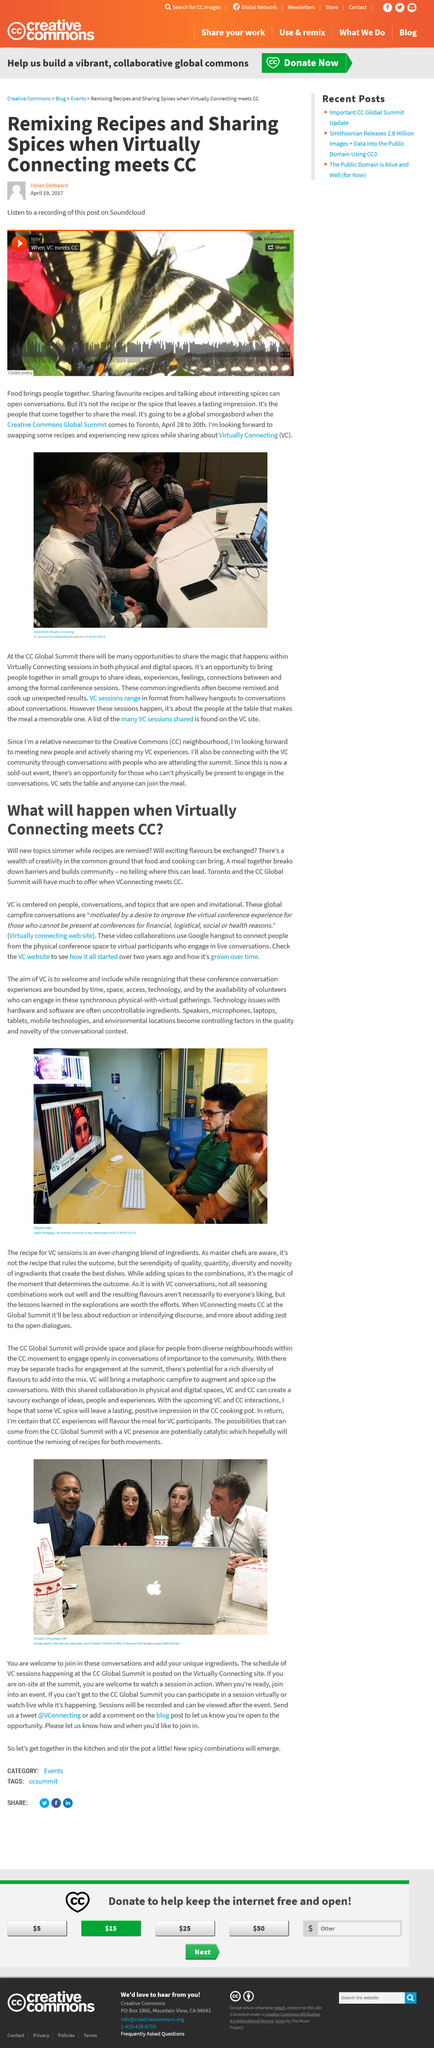Give some essential details in this illustration. You can listen to a recording of this post on Soundcloud. The conversations that are used are known as global campfire sessions. It is known that the article was written by Helen DeWaard. The Creative Commons Global Summit will take place in Toronto from April 28 to 30. Individuals should visit the Virtually Connecting website to gain access to valuable resources and information related to virtual and hybrid events. 